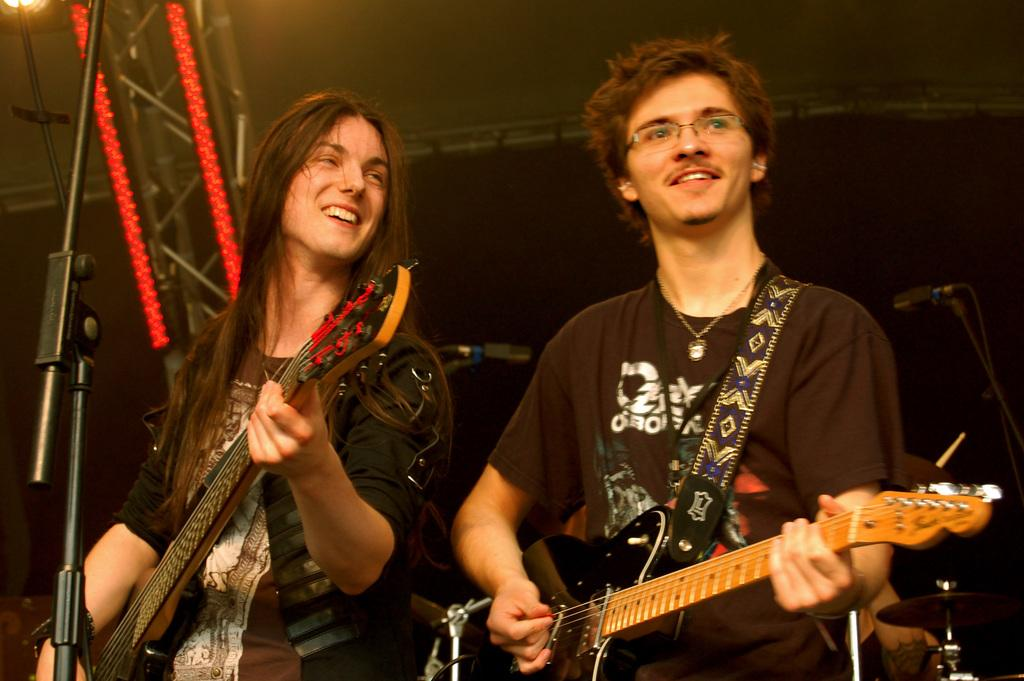How many people are in the image? There are two people in the image. What are the two people doing in the image? The two people are playing guitar. What object is in front of the people? There is a microphone in front of the people. What can be seen in the background of the image? There are metal rods and light visible in the background of the image. What type of taste does the icicle have in the image? There is no icicle present in the image, so it is not possible to determine its taste. 